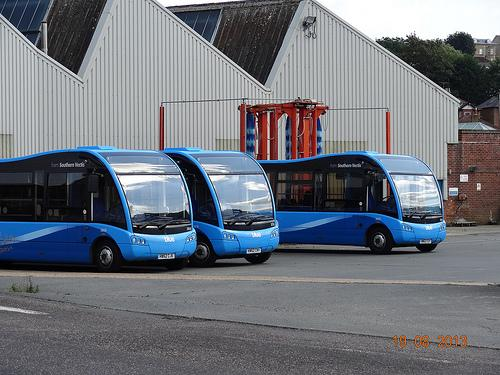Describe the scene's sentiment and quality while mentioning a few objects in the scene. The scene is neutral in sentiment and has good quality, showing three blue buses parked next to each other with trees behind the building. Count how many buses are in the image and list their color. There are three buses in the image, and they are all blue. What is the primary focus of the image, and what do they have in common? The primary focus of the image is three blue buses parked next to each other, all with large see-through windows. List two features of the bus windows in the image. The bus windows are large and see-through. Identify the color and location of the dates displayed in the image. The dates are orange and located at the bottom of the image. Explain if the windows of the buses are visible or not in the image. The windows of the buses are visible and see-through. Describe the surroundings of the buses parked in the image. There are trees behind a building, and red structure with columns and buildings around the buses. Describe any objects or structures beside the buses. There are orange poles beside the buses, red structure with columns, a white-paneled building, and a brick building. Mention any defects or irregularities present on the ground in the image. There are cracks in the ground, green weeds in asphalt, and a white dash in the parking lot. State the object that is found in the parking lot aside from the buses. There is a patch of weeds in the parking lot. What time of day does the image appear to be taken? During the day Is there a yellow pole next to the buses? The poles mentioned next to the buses are orange, not yellow.  Select the correct statement: a) Green bushes in the parking lot b) Orange poles beside the bus c) Yellow trees behind the building b) Orange poles beside the bus Describe the position of the trees in relation to the building. The trees are behind the building. Are the buses curvy, square, or rectangular? Curvy Which bus is the farthest away from the viewer? The blue bus that is farthest away in the image What type of building appears to be located on the right side of the image? A brick building What can be seen through the windows of the buses? They are see-through, but there's no specific view mentioned in the image. Locate the license plate on a bus. On the front of one of the buses Is there a red bus in the image? There are only blue buses in the image, so a mention of a red bus would be misleading. Are the buses parked on grass? The buses are parked on a road or parking lot with cracks and weeds, not on grass. Are the windows on the buses tinted and not see-through? The windows on the buses are described as see-through, so asking about tinted or non-transparent windows is misleading. Are there windows on the ceiling of any structure in the image? Yes, there are windows on the ceiling. How many wheels are there on the third bus? Cannot determine the exact number since only two wheels are visible in the image. Describe the design on the body of the blue bus closest to the viewer. There is a blue design on the body. Is the license plate on the bus green? The license plate mentioned in the image has no color attribute specified, so assuming it's green would be misleading. What is the nature of the roof on the building closest to the trees? Slanted What is the condition of the ground in the parking lot? There are cracks and patches of weeds. Identify the color of the wheels of a bus. Not visible in the image Are there any cracks in the ground? If so, describe them. Yes, there are cracks in the ground. Can you see any purple trees in the background? There are only trees with green leaves mentioned in the image, so asking about purple trees is incorrect. Which color are the buses in the image? Blue What is parked on the road and how many of them are there? Three blue buses What type of windows do the buses have? Large windows Is there grass or weeds in the parking lot? There are green weeds in the parking lot. 